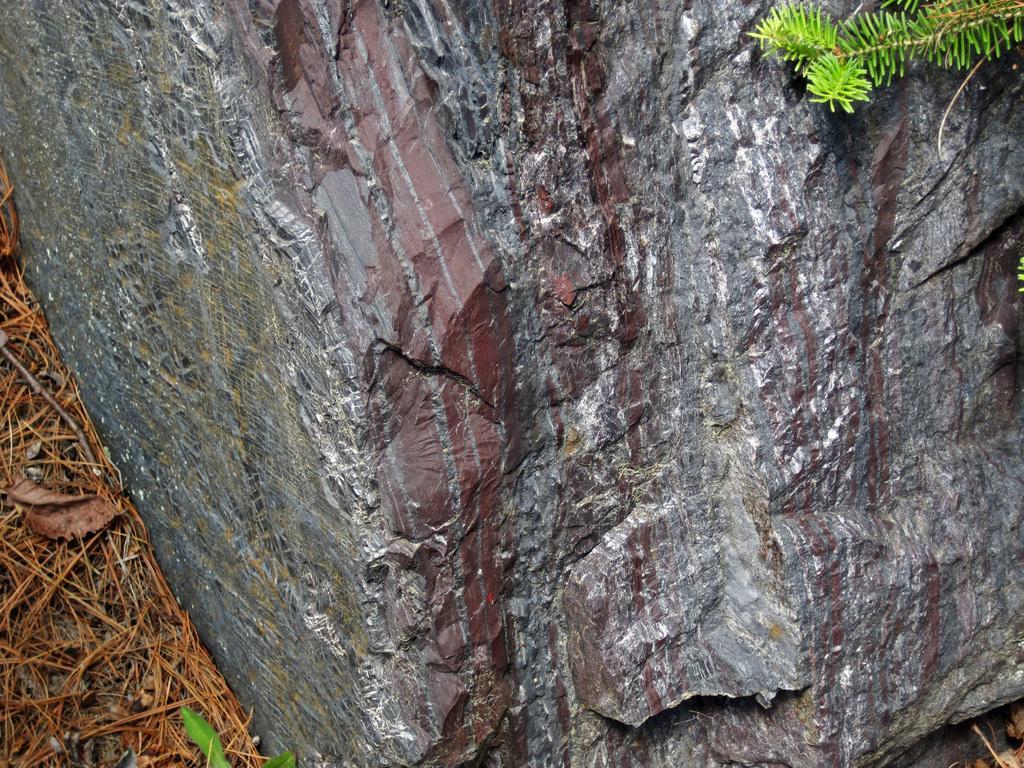Could you give a brief overview of what you see in this image? We can see rock, dried grass and green leaves. 